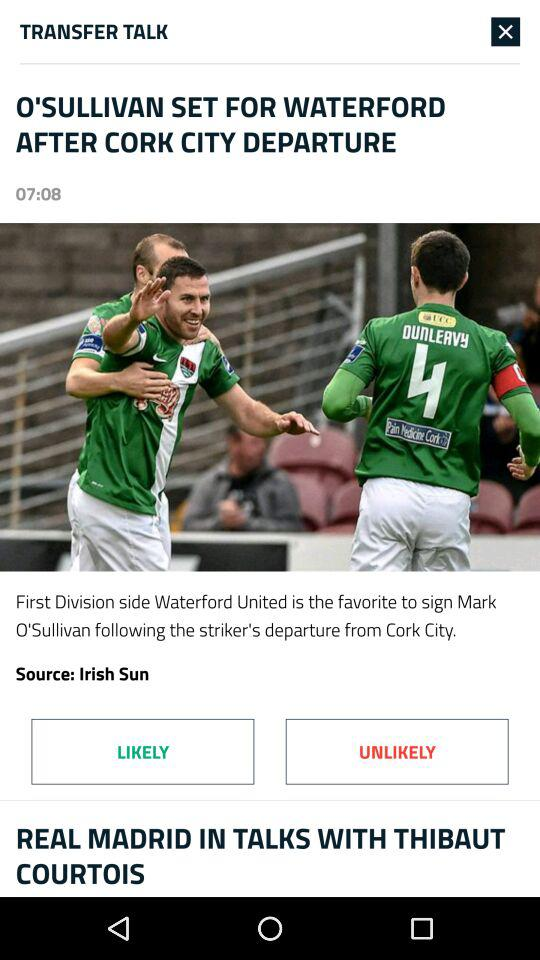Which team is Mark O'Sullivan leaving?
Answer the question using a single word or phrase. Cork City 